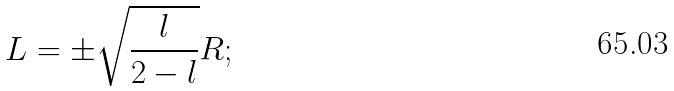<formula> <loc_0><loc_0><loc_500><loc_500>L = \pm \sqrt { \frac { l } { 2 - l } } R ;</formula> 